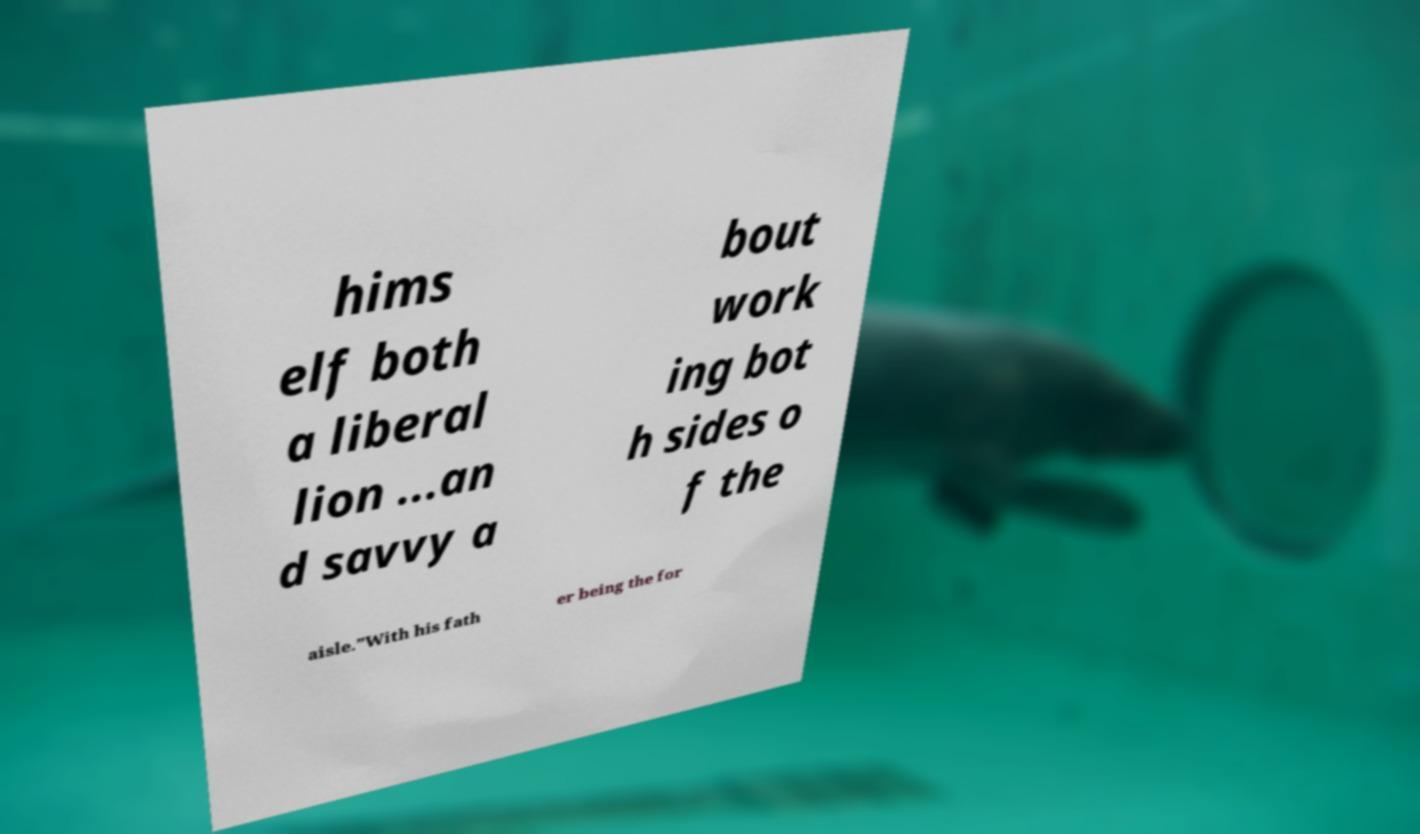Please read and relay the text visible in this image. What does it say? hims elf both a liberal lion ...an d savvy a bout work ing bot h sides o f the aisle.”With his fath er being the for 